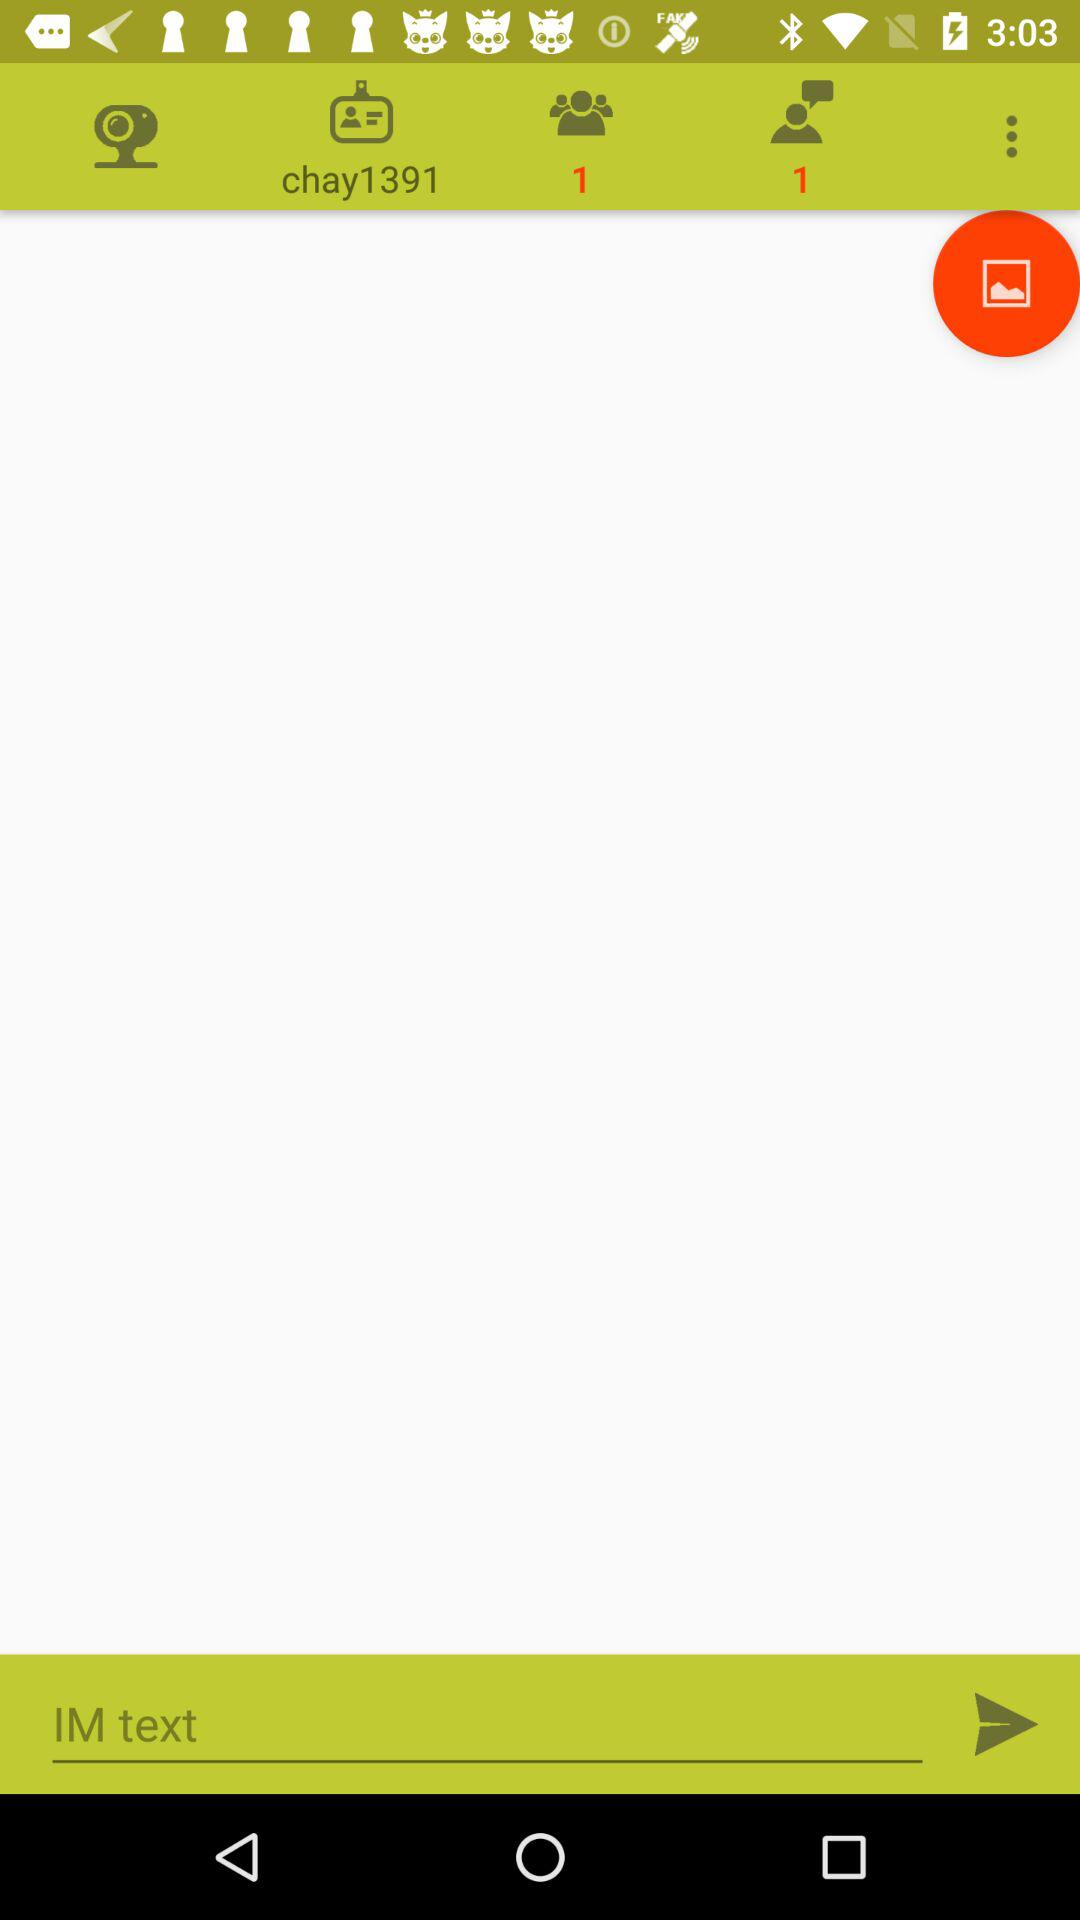What is the username? The username is "chay1391". 